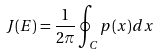<formula> <loc_0><loc_0><loc_500><loc_500>J ( E ) = \frac { 1 } { 2 \pi } \oint _ { C } p ( x ) d x</formula> 